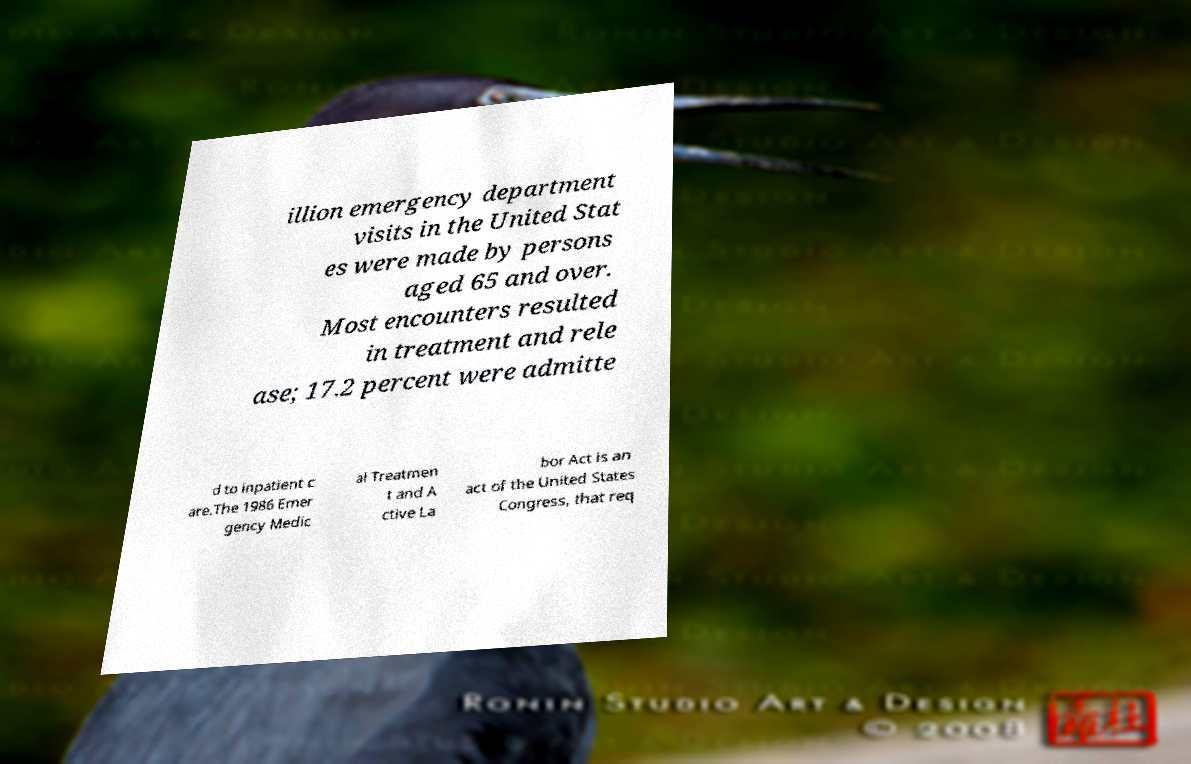I need the written content from this picture converted into text. Can you do that? illion emergency department visits in the United Stat es were made by persons aged 65 and over. Most encounters resulted in treatment and rele ase; 17.2 percent were admitte d to inpatient c are.The 1986 Emer gency Medic al Treatmen t and A ctive La bor Act is an act of the United States Congress, that req 